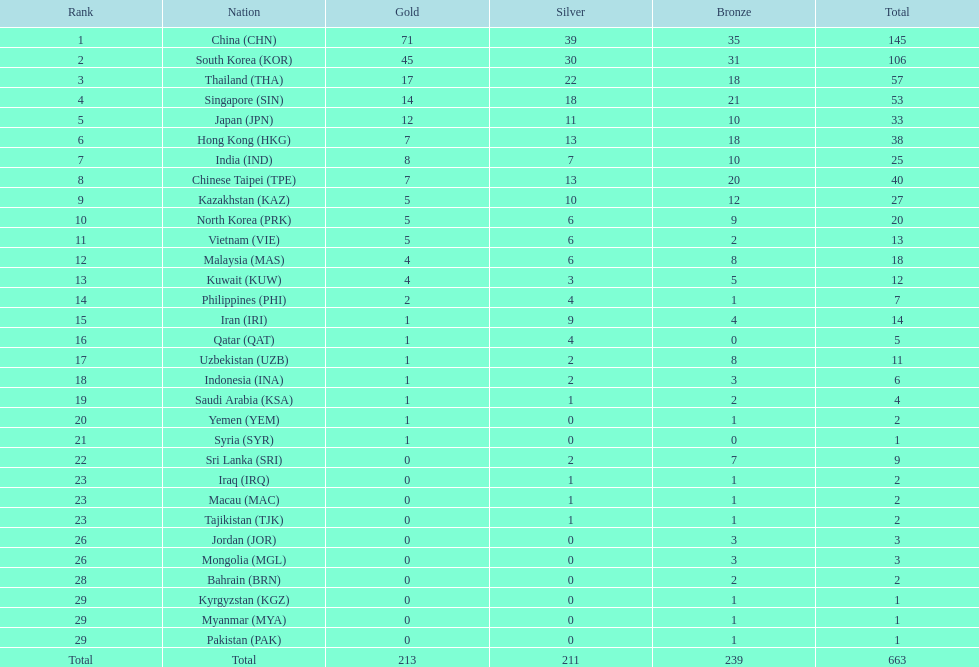What was iran's medal tally? 14. 